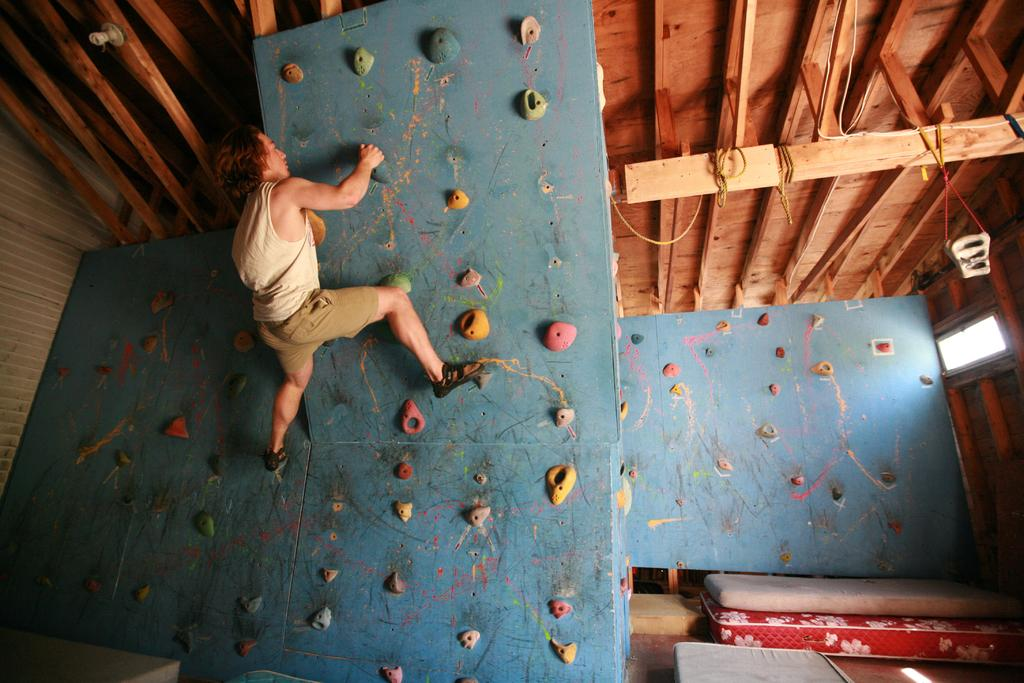What is the man in the image doing? The man is climbing the wall in the image. What can be seen on the floor in the image? There are beds on the floor in the image. What type of objects are visible in the background of the image? There are wooden sticks visible in the background of the image. What is the source of light in the background of the image? There is light in the background of the image. Can you see a kitten on a boat in the image? There is no boat or kitten present in the image. 